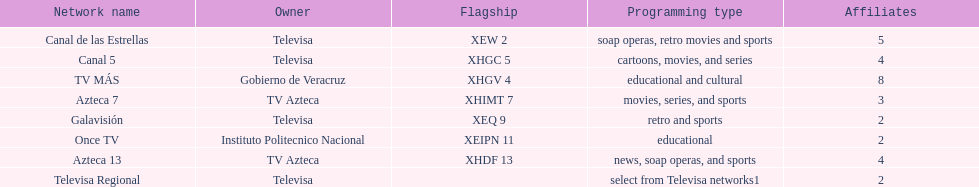What is the number of networks that broadcast soap operas? 2. 